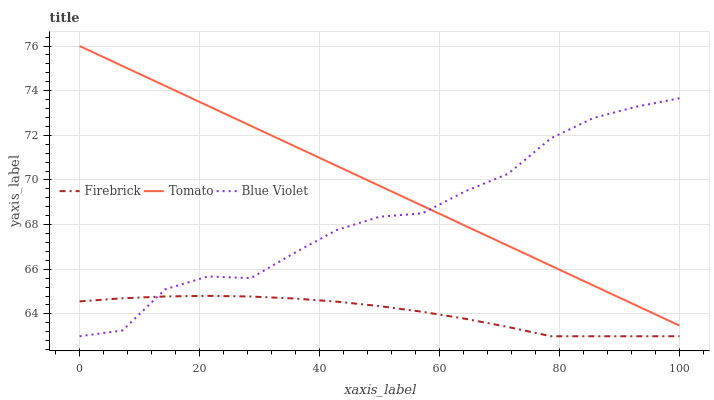Does Firebrick have the minimum area under the curve?
Answer yes or no. Yes. Does Tomato have the maximum area under the curve?
Answer yes or no. Yes. Does Blue Violet have the minimum area under the curve?
Answer yes or no. No. Does Blue Violet have the maximum area under the curve?
Answer yes or no. No. Is Tomato the smoothest?
Answer yes or no. Yes. Is Blue Violet the roughest?
Answer yes or no. Yes. Is Firebrick the smoothest?
Answer yes or no. No. Is Firebrick the roughest?
Answer yes or no. No. Does Firebrick have the lowest value?
Answer yes or no. Yes. Does Tomato have the highest value?
Answer yes or no. Yes. Does Blue Violet have the highest value?
Answer yes or no. No. Is Firebrick less than Tomato?
Answer yes or no. Yes. Is Tomato greater than Firebrick?
Answer yes or no. Yes. Does Tomato intersect Blue Violet?
Answer yes or no. Yes. Is Tomato less than Blue Violet?
Answer yes or no. No. Is Tomato greater than Blue Violet?
Answer yes or no. No. Does Firebrick intersect Tomato?
Answer yes or no. No. 